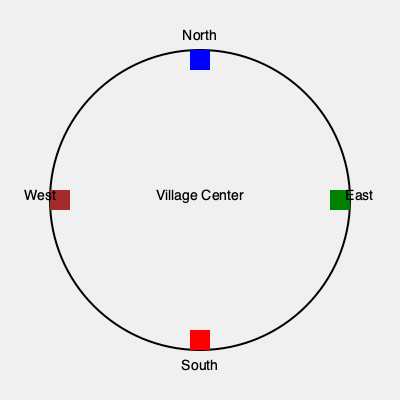In the traditional village layout shown above, which direction should the men's gathering place be located according to ancestral customs, and why is this significant? To answer this question, we need to consider the traditional village layout and its significance:

1. The village is represented by a circular structure, symbolizing unity and equality.

2. The cardinal directions are clearly marked: North (top), East (right), South (bottom), and West (left).

3. In many traditional societies, the East is associated with new beginnings, enlightenment, and spiritual awakening. It's where the sun rises, symbolizing birth and renewal.

4. The West, on the other hand, is often associated with endings, wisdom, and the ancestors. It's where the sun sets, symbolizing death and the passage to the afterlife.

5. In patriarchal societies, men are typically seen as the leaders and decision-makers. They are expected to possess wisdom and maintain connections with the ancestors.

6. Therefore, the men's gathering place would traditionally be located in the West, represented by the brown square in the diagram.

7. This placement is significant because it:
   a) Associates men with wisdom and ancestral knowledge
   b) Places them as guardians of tradition and the link between the living and the dead
   c) Reinforces their role as decision-makers for the community

8. In contrast, women's spaces might be located in the East, associated with nurturing and new life, reflecting traditional gender roles.
Answer: West, symbolizing wisdom and ancestral connection. 